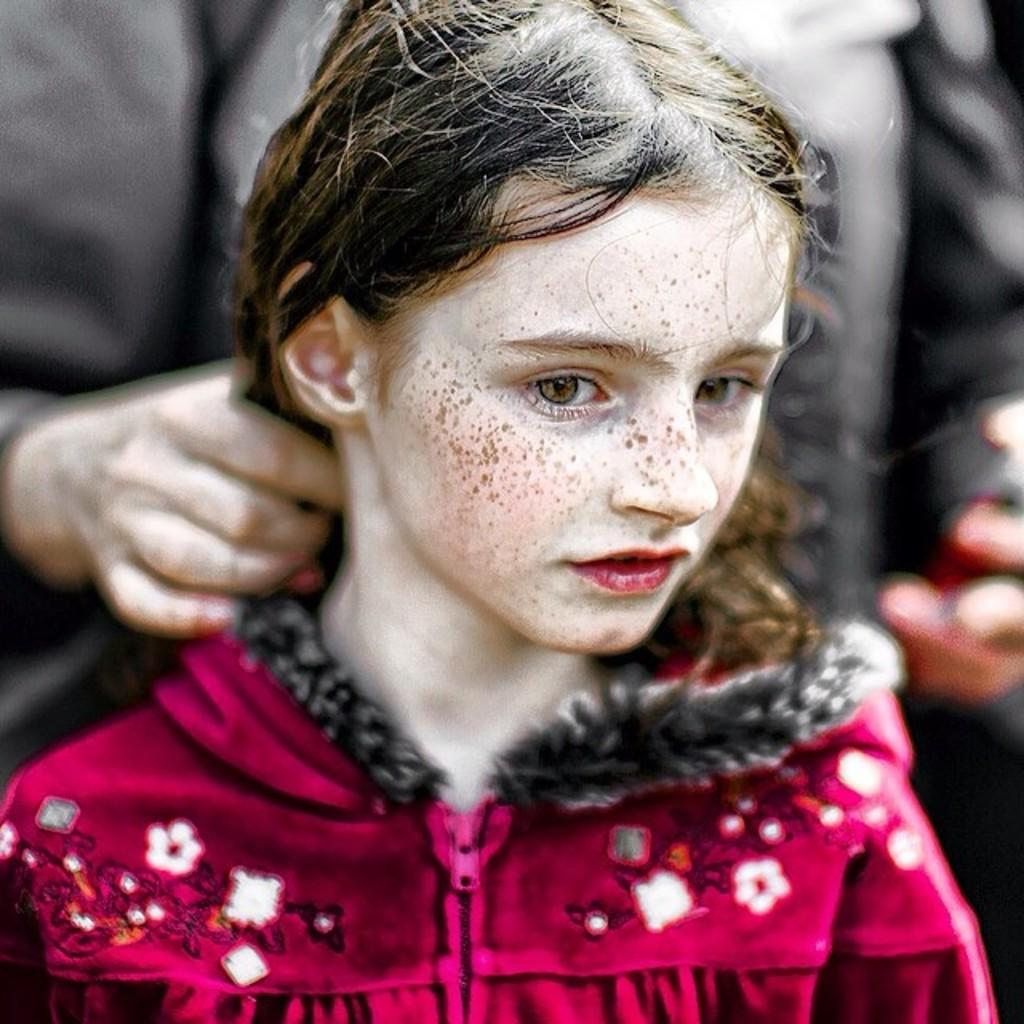What is the girl in the image wearing? The girl in the image is wearing a red dress. Can you describe the person in the background? The person in the background is holding a girl's hair. How would you describe the background of the image? The background of the image is blurred. What type of bag is the girl using to store her quill in the image? There is no bag or quill present in the image. 